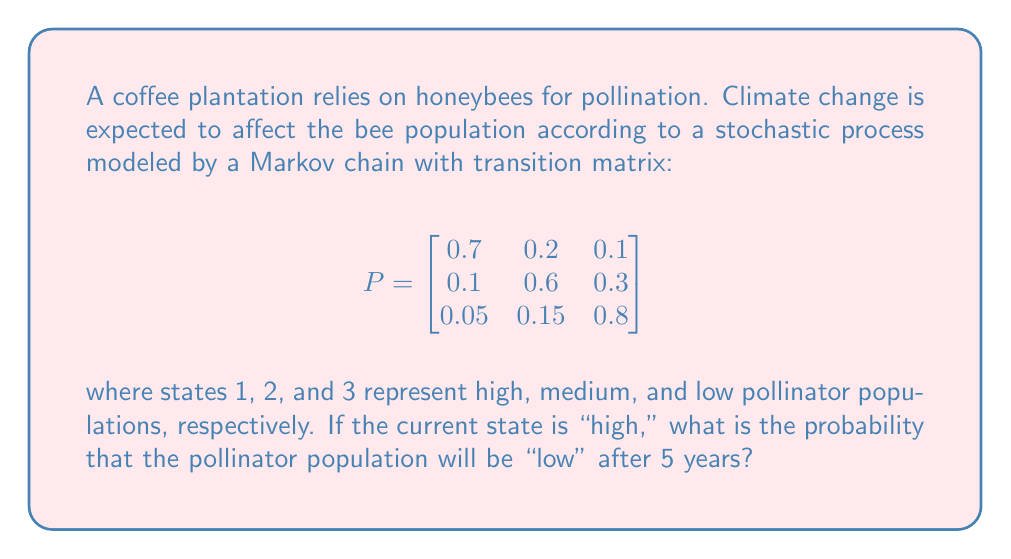Solve this math problem. To solve this problem, we need to calculate the 5-step transition probability from state 1 (high) to state 3 (low). This can be done by raising the transition matrix P to the 5th power and looking at the element in the first row, third column.

Steps:
1) First, we need to calculate $P^5$. This can be done by multiplying P by itself 5 times.

2) Using a computer algebra system or matrix multiplication, we get:

   $$P^5 = \begin{bmatrix}
   0.40657 & 0.28686 & 0.30657 \\
   0.31343 & 0.31343 & 0.37314 \\
   0.23429 & 0.25714 & 0.50857
   \end{bmatrix}$$

3) The probability we're looking for is the element in the first row, third column of $P^5$, which represents the probability of transitioning from state 1 (high) to state 3 (low) in 5 steps.

4) This probability is approximately 0.30657 or about 30.66%.

This result suggests that even if the pollinator population starts high, there's a significant chance (about 30.66%) that it will be low after 5 years, highlighting the potential long-term impact of climate change on pollinator populations.
Answer: $0.30657$ (or approximately $30.66\%$) 